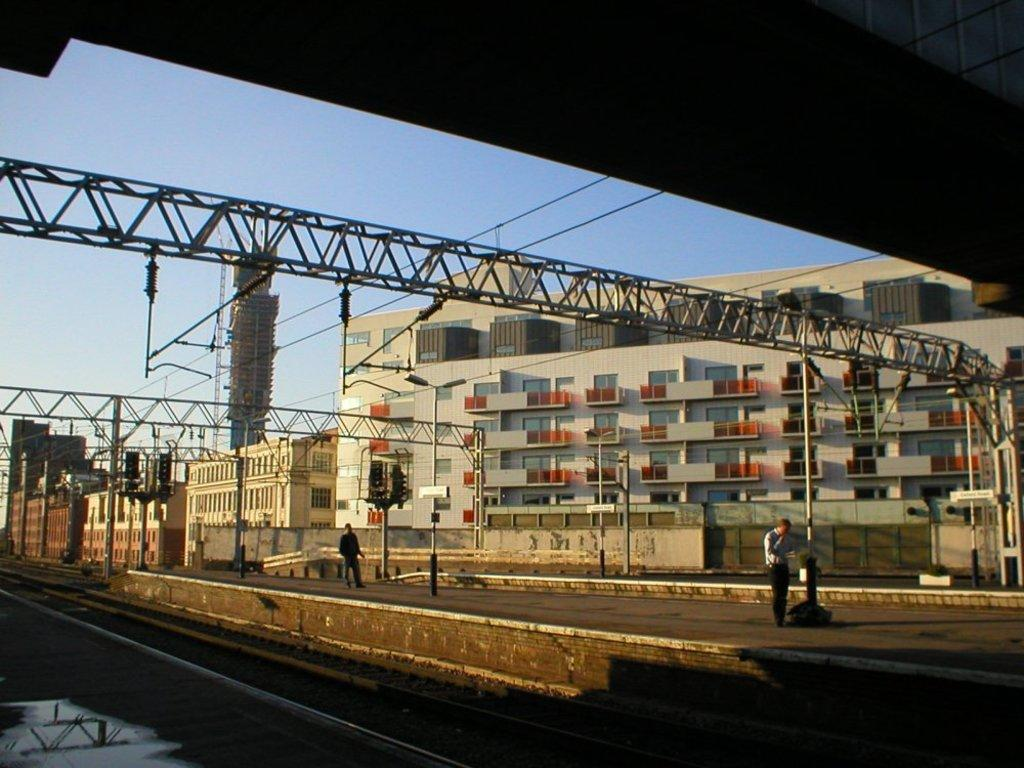What type of transportation infrastructure is visible in the image? There are railway tracks in the image. What are the people in the image doing? People are walking on a platform in the image. What else can be seen in the image besides the railway tracks and people? Wires, signal poles, a wall, a building, and the sky are visible in the image. What type of dinner is being served on the platform in the image? There is no dinner being served in the image; it features railway tracks, people walking on a platform, and other infrastructure-related elements. 